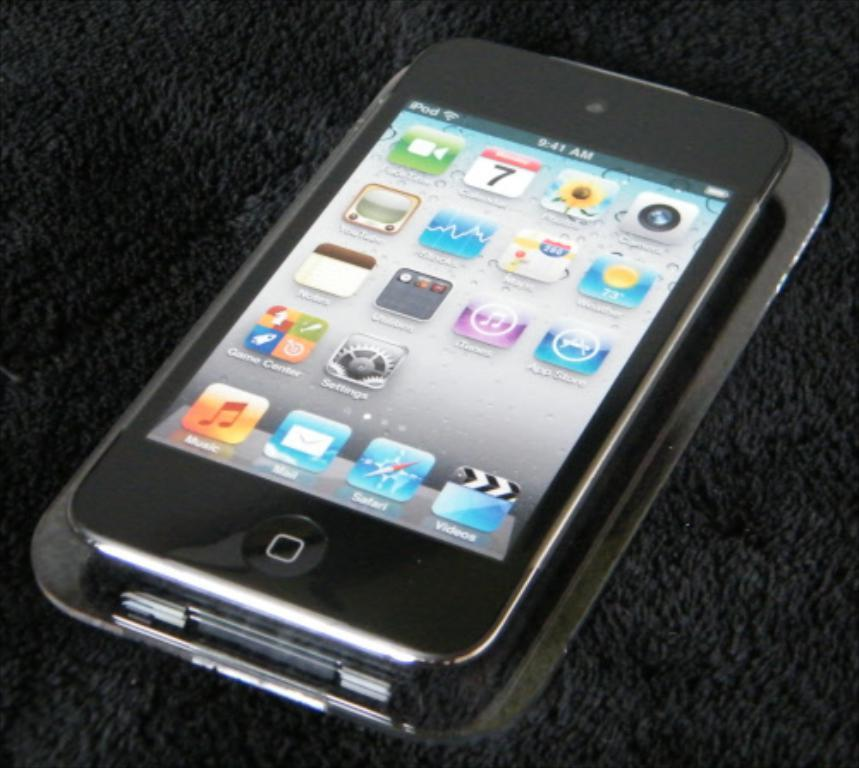<image>
Summarize the visual content of the image. An iPod has the time as 9:41 am. 